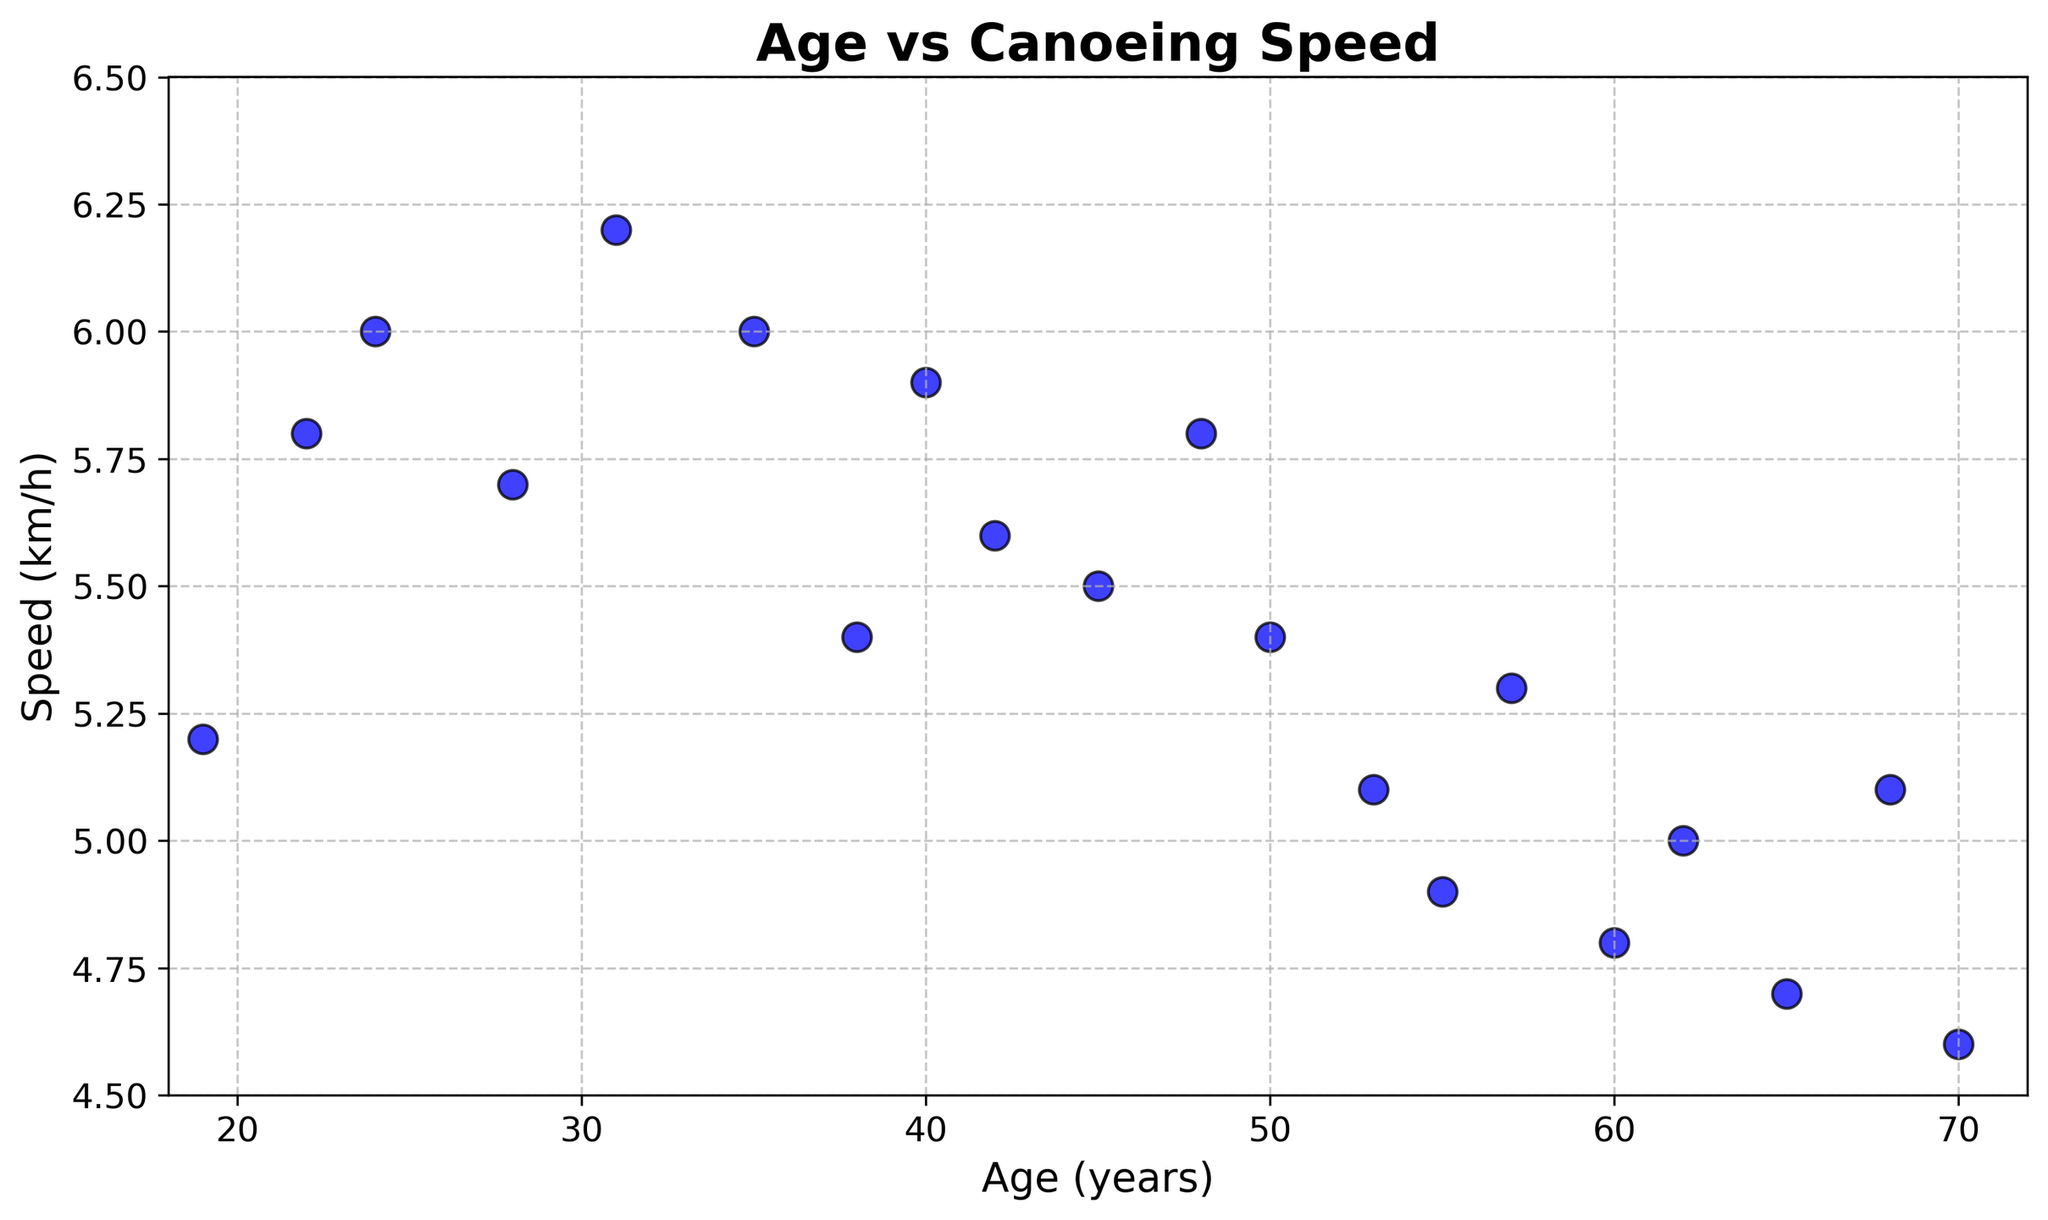What's the age range of the participants? The x-axis represents age, and the scatter plot spans from the lowest age on the leftmost point to the highest age on the rightmost point. The range goes from 19 to 70 years.
Answer: 19 to 70 What is the average canoeing speed of participants aged above 50? Check the data points for participants aged above 50 (53, 55, 57, 60, 62, 65, 68, 70) and their corresponding speeds (5.1, 4.9, 5.3, 4.8, 5.0, 4.7, 5.1, 4.6). Calculate the average: (5.1 + 4.9 + 5.3 + 4.8 + 5.0 + 4.7 + 5.1 + 4.6) / 8 = 39.5 / 8.
Answer: 4.94 km/h Which age group has the highest canoeing speed and what is it? Locate the highest y-axis value which corresponds to the speed. The highest speed is 6.2 km/h, which is achieved by the 31-year-old participant.
Answer: 31 years with 6.2 km/h Do younger participants generally have higher canoeing speeds than older participants? Compare the trend of the data points from left to right. Generally, younger participants (aged 19 to 35) tend to have higher speeds compared to older participants (aged 55 to 70).
Answer: Yes Is there a noticeable decrease in speed as participants age? Observe the scatter plot for any trend lines. While the trend is not perfectly linear, there is a general decrease in speed as age increases, particularly noticeable after 50 years.
Answer: Yes What is the speed difference between the youngest and the oldest participant? Identify the speeds of the 19-year-old (5.2 km/h) and the 70-year-old (4.6 km/h). Subtract the speed of the oldest participant from the youngest participant's speed: 5.2 - 4.6 = 0.6 km/h.
Answer: 0.6 km/h Which age has multiple participants with the same speed and what is that speed? Find ages with repeated speeds by reviewing the scatter plot points. Participants aged 24 and 35 both have a canoeing speed of 6.0 km/h.
Answer: 24 and 35 years with 6.0 km/h Do any participants aged 40 or above have canoeing speeds above 6.0 km/h? Review the scatter plot for participants aged 40 or above and check their speeds. No participant aged 40 or above has a speed exceeding 6.0 km/h.
Answer: No What is the median speed value of all participants? List all the speeds in ascending order and find the middle value(s): 4.6, 4.7, 4.8, 4.9, 5.0, 5.1, 5.1, 5.2, 5.3, 5.4, 5.4, 5.5, 5.6, 5.7, 5.8, 5.8, 5.9, 6.0, 6.0, 6.2. The middle two values are both 5.4 and 5.4, so the median is (5.4 + 5.4) / 2 = 5.4
Answer: 5.4 km/h 